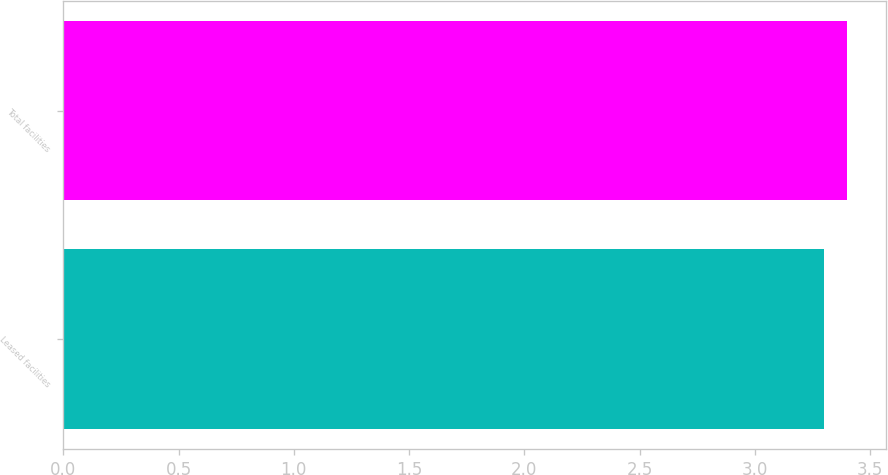Convert chart to OTSL. <chart><loc_0><loc_0><loc_500><loc_500><bar_chart><fcel>Leased facilities<fcel>Total facilities<nl><fcel>3.3<fcel>3.4<nl></chart> 